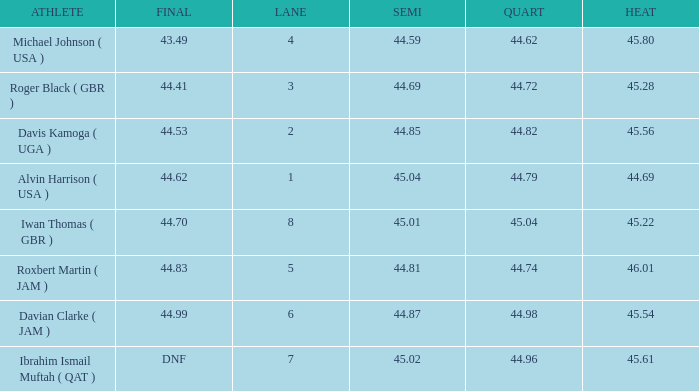When a lane of 4 possesses a quart above 4 None. 